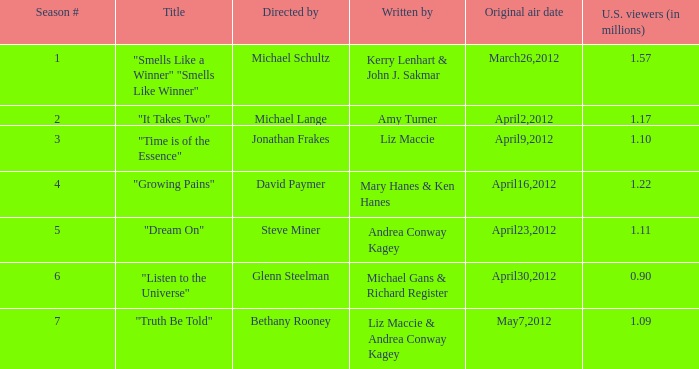When was the initial transmission of the episode called "truth be told"? May7,2012. 